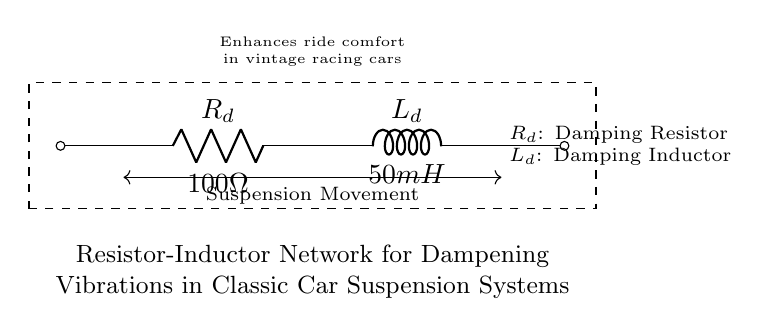What is the resistance value in this circuit? The resistance value is found next to the resistor symbol in the diagram, labeled as $R_d$. It indicates the resistance in ohms.
Answer: 100 ohms What is the inductance value in this circuit? The inductance value can be found next to the inductor symbol in the schematic, marked as $L_d$. It indicates the inductance in henries or millihenries.
Answer: 50 millihenries What component is used to dampen vibrations in the circuit? The circuit features a damping resistor and inductor, specifically a resistor labeled as $R_d$ and an inductor labeled as $L_d$, which help to reduce vibrations in the suspension system.
Answer: Damping resistor and inductor How does this resistor-inductor network enhance ride comfort? The resistor-inductor network works together to soften the effects of suspension movements by providing a controlled damping effect, minimizing harshness and abrupt changes during racing.
Answer: By controlling damping What does the dashed rectangle in the diagram signify? The dashed rectangle surrounds the entire circuit, indicating that all the components within it work collectively as part of a single system for vibration dampening in the suspension.
Answer: Circuit system What is the purpose of the resistor in this circuit? The resistor serves to dissipate energy and regulate the damping effect within the suspension system, preventing oscillations and improving stability during operation.
Answer: Energy dissipation 